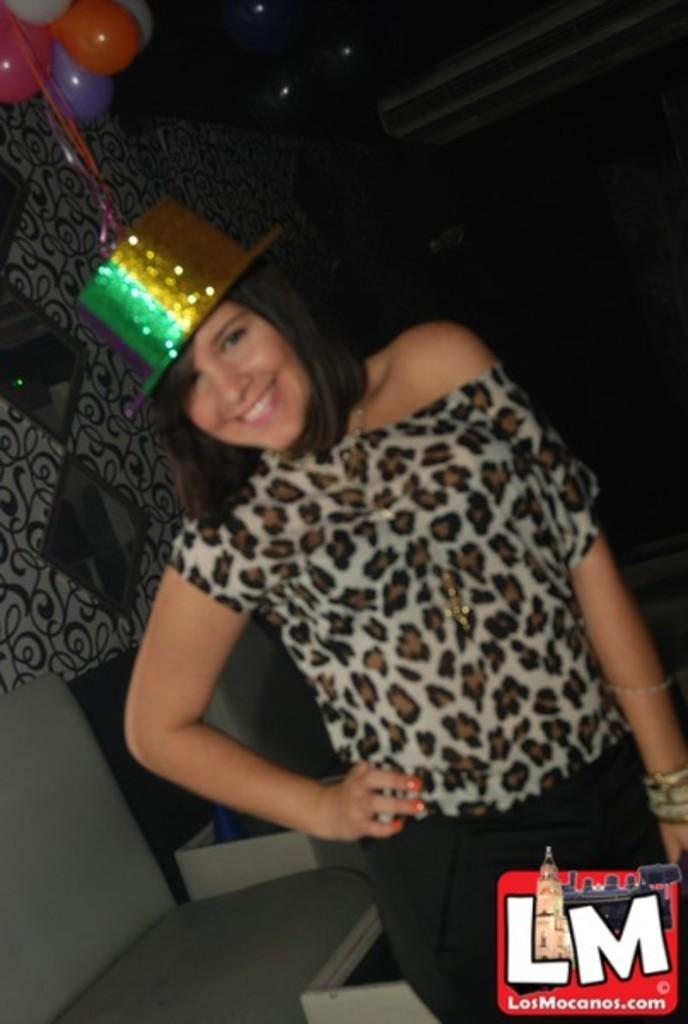Please provide a concise description of this image. In the center of the image there is a woman standing on the ground. In the background we can see balloons, mirrors and wall. 